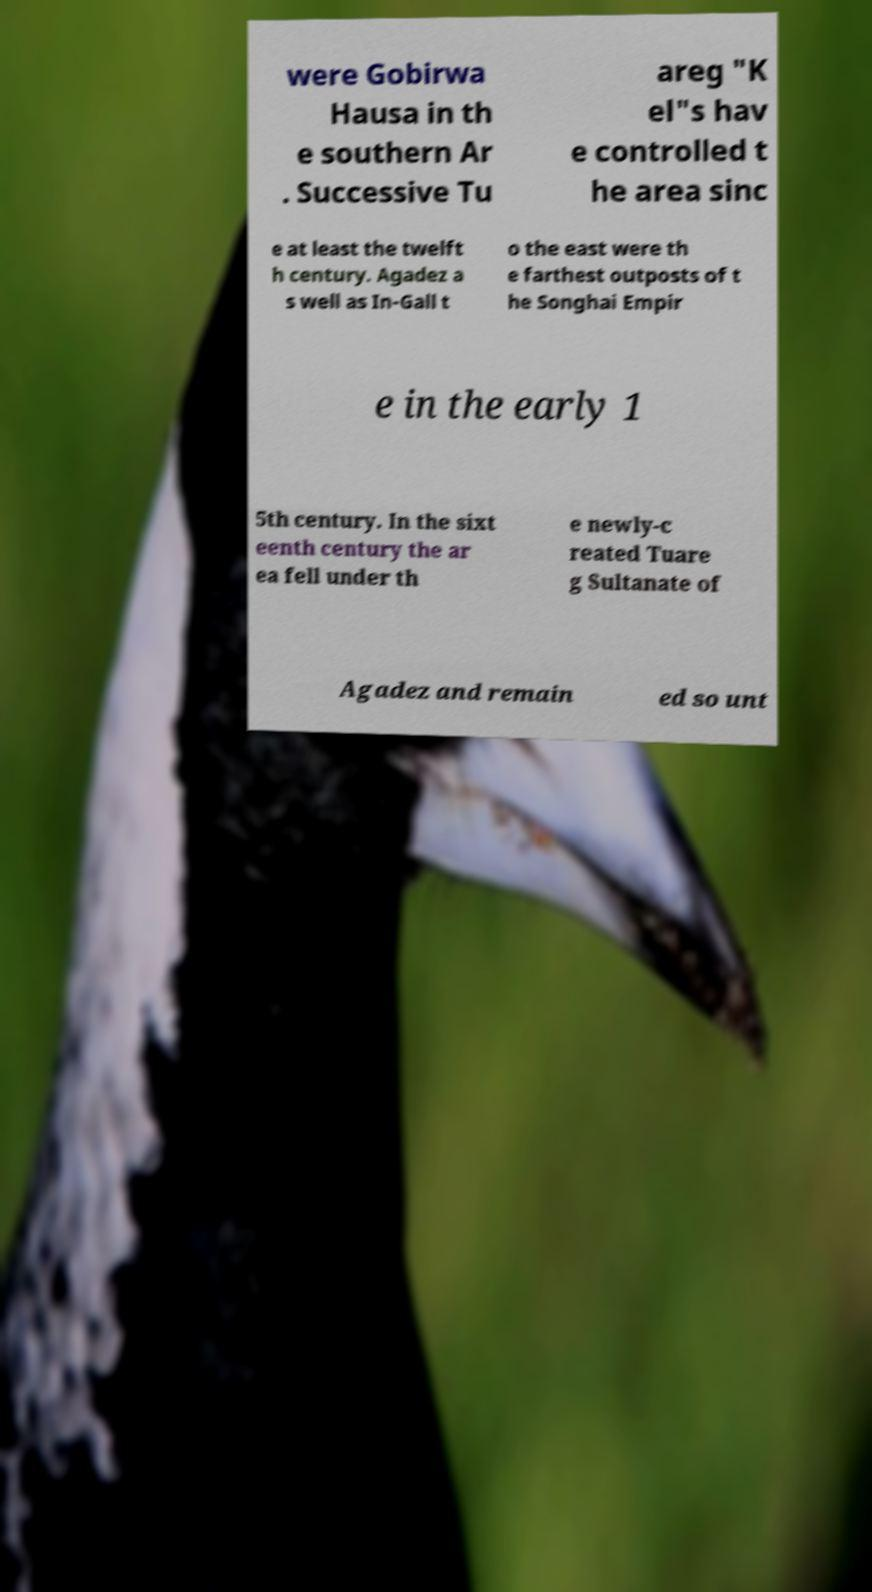Please identify and transcribe the text found in this image. were Gobirwa Hausa in th e southern Ar . Successive Tu areg "K el"s hav e controlled t he area sinc e at least the twelft h century. Agadez a s well as In-Gall t o the east were th e farthest outposts of t he Songhai Empir e in the early 1 5th century. In the sixt eenth century the ar ea fell under th e newly-c reated Tuare g Sultanate of Agadez and remain ed so unt 